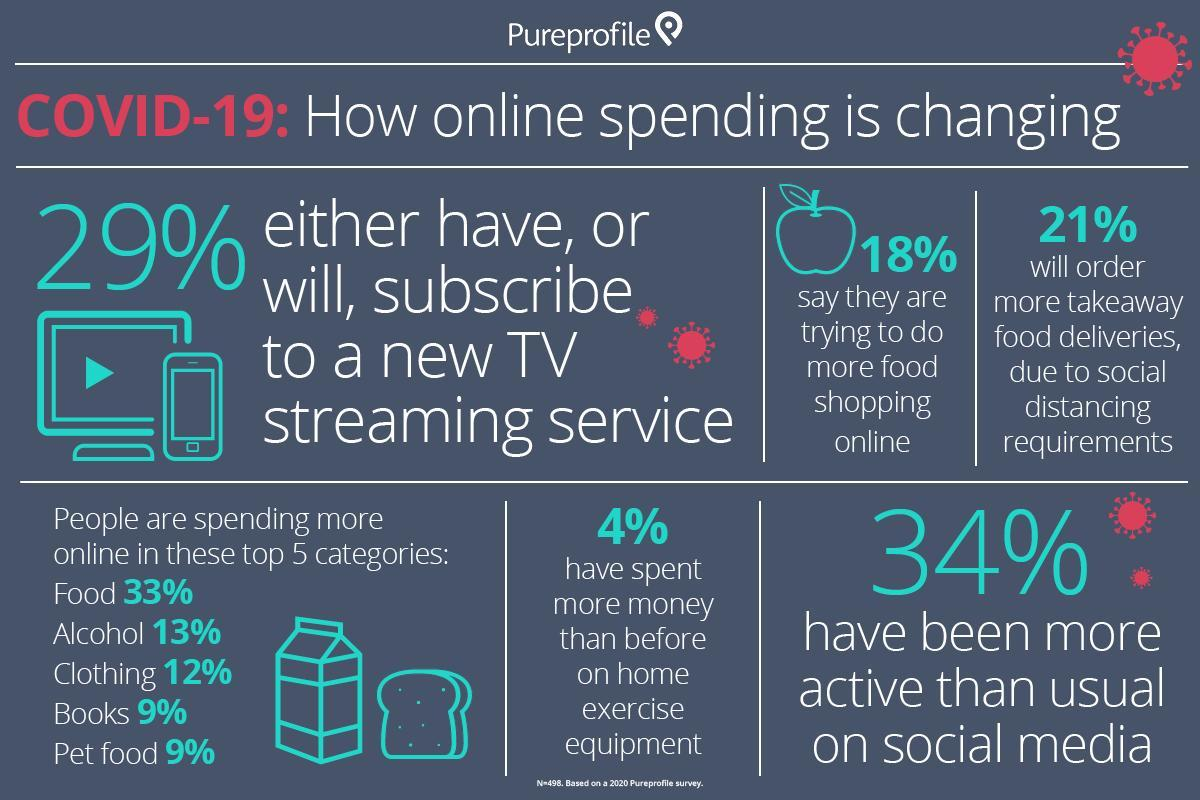What percentage of people buy books online due to the impact of  COVID-19?
Answer the question with a short phrase. 9% What percentage of people say that they are trying to do more food shopping online due to the impact of COVID-19? 18% 